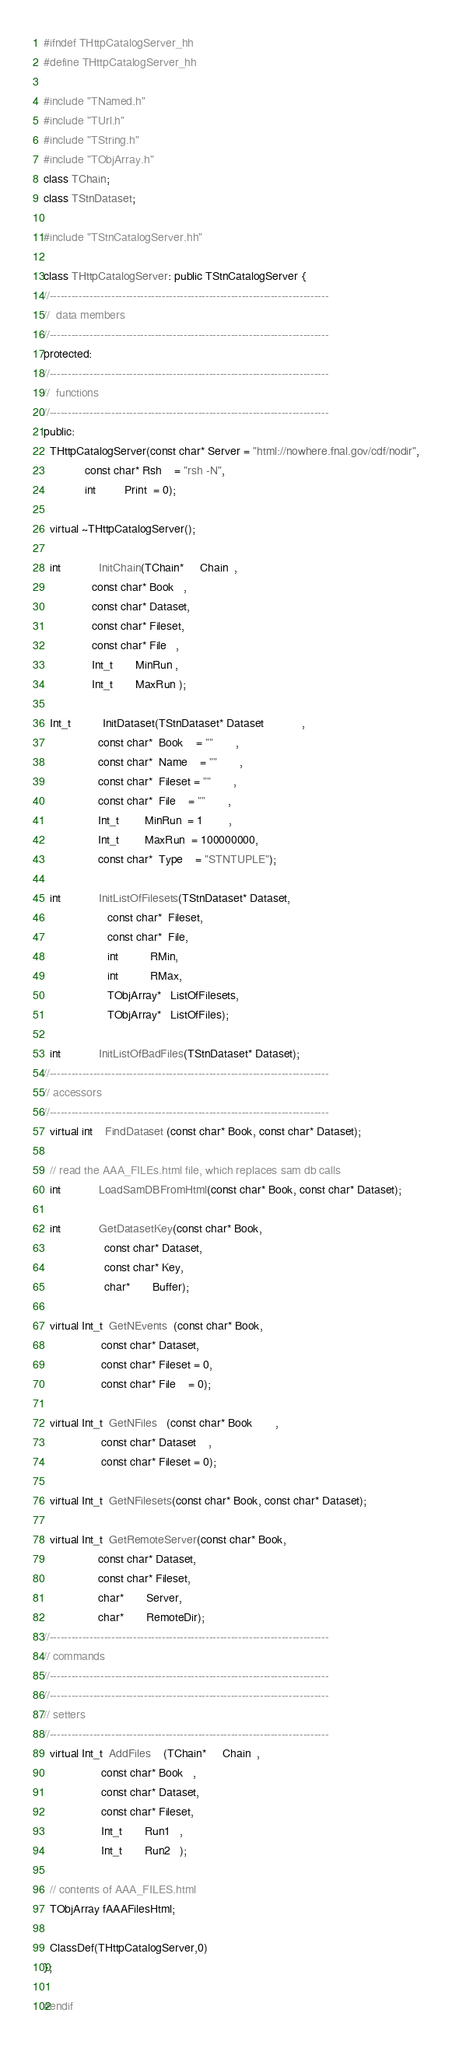<code> <loc_0><loc_0><loc_500><loc_500><_C++_>#ifndef THttpCatalogServer_hh
#define THttpCatalogServer_hh

#include "TNamed.h"
#include "TUrl.h"
#include "TString.h"
#include "TObjArray.h"
class TChain;
class TStnDataset;

#include "TStnCatalogServer.hh"

class THttpCatalogServer: public TStnCatalogServer {
//-----------------------------------------------------------------------------
//  data members
//-----------------------------------------------------------------------------
protected:
//-----------------------------------------------------------------------------
//  functions
//-----------------------------------------------------------------------------
public:
  THttpCatalogServer(const char* Server = "html://nowhere.fnal.gov/cdf/nodir",
		     const char* Rsh    = "rsh -N",
		     int         Print  = 0);

  virtual ~THttpCatalogServer();

  int            InitChain(TChain*     Chain  ,
			   const char* Book   ,
			   const char* Dataset, 
			   const char* Fileset,
			   const char* File   ,
			   Int_t       MinRun ,
			   Int_t       MaxRun );

  Int_t          InitDataset(TStnDataset* Dataset            ,
			     const char*  Book    = ""       ,
			     const char*  Name    = ""       ,
			     const char*  Fileset = ""       ,
			     const char*  File    = ""       ,
			     Int_t        MinRun  = 1        ,
			     Int_t        MaxRun  = 100000000,
			     const char*  Type    = "STNTUPLE");

  int            InitListOfFilesets(TStnDataset* Dataset, 
				    const char*  Fileset,
				    const char*  File,
				    int          RMin,
				    int          RMax,
				    TObjArray*   ListOfFilesets,
				    TObjArray*   ListOfFiles);

  int            InitListOfBadFiles(TStnDataset* Dataset);
//-----------------------------------------------------------------------------
// accessors
//-----------------------------------------------------------------------------
  virtual int    FindDataset (const char* Book, const char* Dataset);

  // read the AAA_FILEs.html file, which replaces sam db calls
  int            LoadSamDBFromHtml(const char* Book, const char* Dataset);

  int            GetDatasetKey(const char* Book, 
			       const char* Dataset,
			       const char* Key,
			       char*       Buffer);

  virtual Int_t  GetNEvents  (const char* Book, 
			      const char* Dataset, 
			      const char* Fileset = 0,
			      const char* File    = 0);

  virtual Int_t  GetNFiles   (const char* Book       , 
			      const char* Dataset    ,
			      const char* Fileset = 0);
  
  virtual Int_t  GetNFilesets(const char* Book, const char* Dataset);

  virtual Int_t  GetRemoteServer(const char* Book,
				 const char* Dataset, 
				 const char* Fileset,
				 char*       Server,
				 char*       RemoteDir);
//-----------------------------------------------------------------------------
// commands
//-----------------------------------------------------------------------------
//-----------------------------------------------------------------------------
// setters
//-----------------------------------------------------------------------------
  virtual Int_t  AddFiles    (TChain*     Chain  ,
			      const char* Book   ,
			      const char* Dataset, 
			      const char* Fileset,
			      Int_t       Run1   ,
			      Int_t       Run2   );

  // contents of AAA_FILES.html
  TObjArray fAAAFilesHtml;
  
  ClassDef(THttpCatalogServer,0)
};

#endif
</code> 